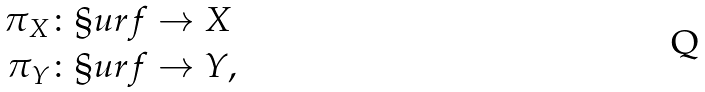<formula> <loc_0><loc_0><loc_500><loc_500>\pi _ { X } & \colon \S u r f \to X \\ \pi _ { Y } & \colon \S u r f \to Y ,</formula> 